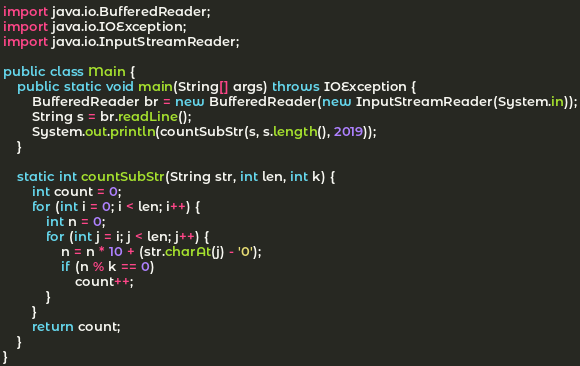<code> <loc_0><loc_0><loc_500><loc_500><_Java_>import java.io.BufferedReader;
import java.io.IOException;
import java.io.InputStreamReader;

public class Main {
	public static void main(String[] args) throws IOException {
		BufferedReader br = new BufferedReader(new InputStreamReader(System.in));
		String s = br.readLine();
		System.out.println(countSubStr(s, s.length(), 2019));
	}

	static int countSubStr(String str, int len, int k) {
		int count = 0;
		for (int i = 0; i < len; i++) {
			int n = 0;
			for (int j = i; j < len; j++) {
				n = n * 10 + (str.charAt(j) - '0');
				if (n % k == 0)
					count++;
			}
		}
		return count;
	}
}
</code> 